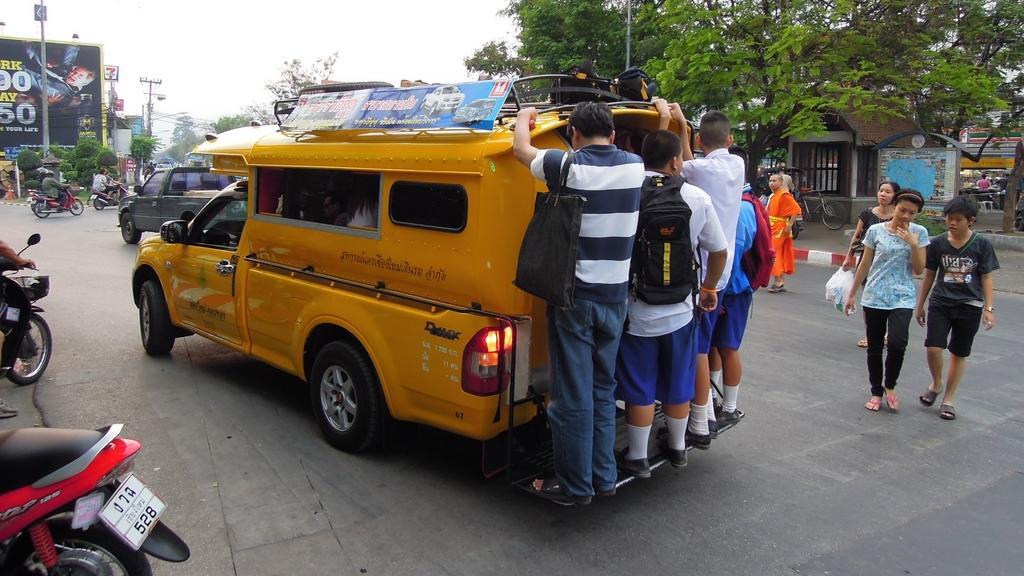Can you describe this image briefly? In this image I can a road and on it I can see few vehicles and few people. I can also see trees, a board, few pills and few people on their vehicles. Here I can see few people are carrying bags. 